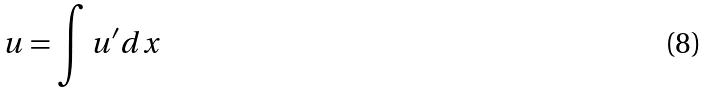Convert formula to latex. <formula><loc_0><loc_0><loc_500><loc_500>u = \int u ^ { \prime } d x</formula> 